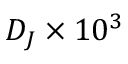Convert formula to latex. <formula><loc_0><loc_0><loc_500><loc_500>D _ { J } \times 1 0 ^ { 3 }</formula> 